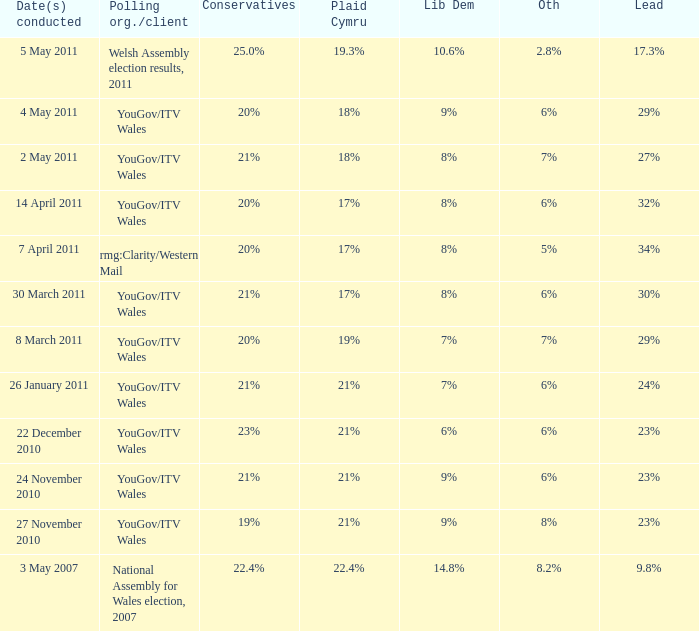Name the others for cons of 21% and lead of 24% 6%. 